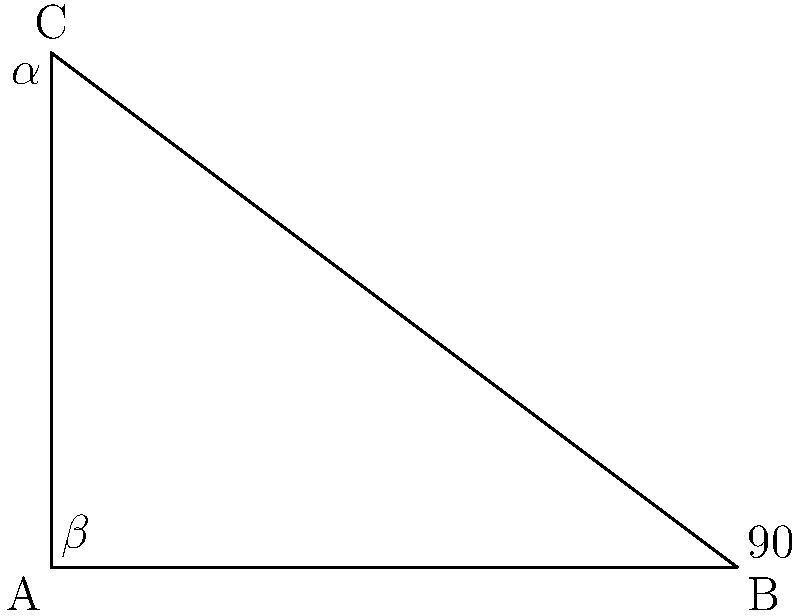In a right-angled triangle ABC used for structural engineering calculations, angle B is 90°, and angle α at C is 36.87°. What is the measure of angle β at A? To solve this problem, we'll use the properties of complementary angles in a right-angled triangle:

1. In a right-angled triangle, the sum of all angles is 180°.
2. The two acute angles (α and β) are complementary, meaning they add up to 90°.

Step 1: Write the equation for the sum of angles in the triangle:
$$ \alpha + \beta + 90° = 180° $$

Step 2: Substitute the known value of α:
$$ 36.87° + \beta + 90° = 180° $$

Step 3: Simplify the equation:
$$ \beta + 126.87° = 180° $$

Step 4: Solve for β:
$$ \beta = 180° - 126.87° = 53.13° $$

Alternatively, we could have used the complementary angle property:
$$ \alpha + \beta = 90° $$
$$ \beta = 90° - 36.87° = 53.13° $$

Therefore, the measure of angle β at A is 53.13°.
Answer: 53.13° 